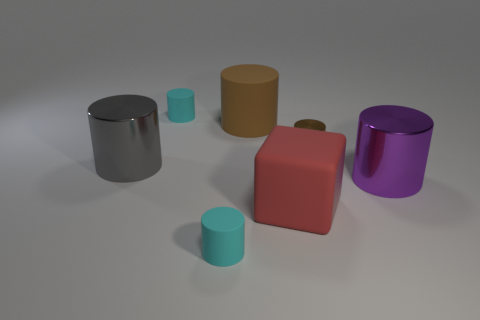Subtract all gray cylinders. How many cylinders are left? 5 Subtract all tiny brown cylinders. How many cylinders are left? 5 Subtract all red cylinders. Subtract all brown blocks. How many cylinders are left? 6 Add 3 large cyan cylinders. How many objects exist? 10 Subtract all cubes. How many objects are left? 6 Subtract all large red blocks. Subtract all large green cylinders. How many objects are left? 6 Add 1 small cyan matte things. How many small cyan matte things are left? 3 Add 3 small brown things. How many small brown things exist? 4 Subtract 0 green cubes. How many objects are left? 7 